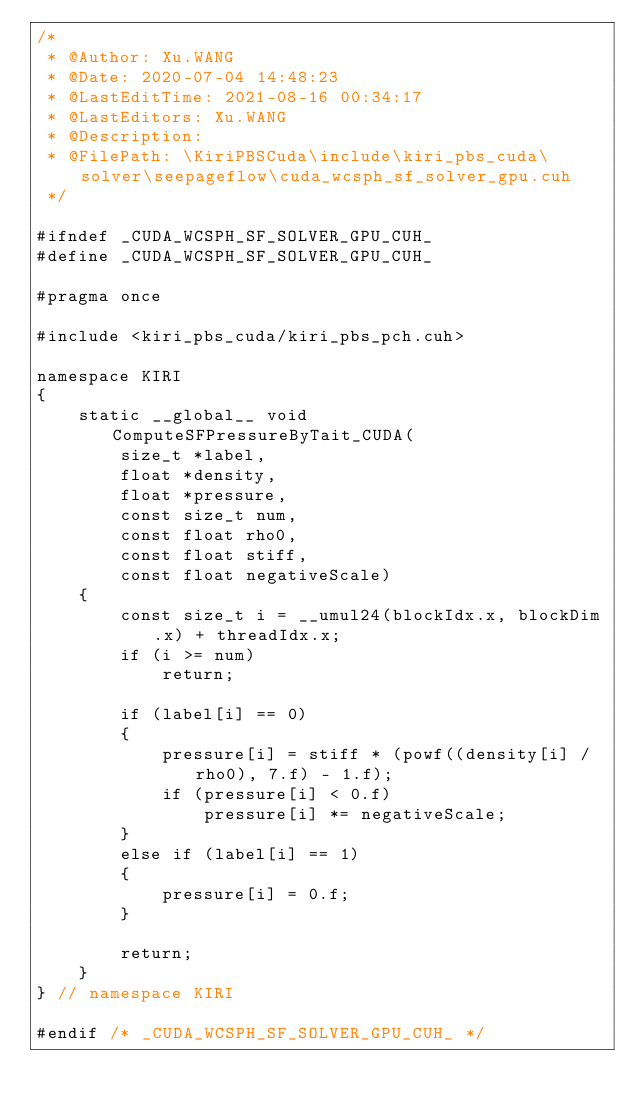<code> <loc_0><loc_0><loc_500><loc_500><_Cuda_>/*
 * @Author: Xu.WANG
 * @Date: 2020-07-04 14:48:23
 * @LastEditTime: 2021-08-16 00:34:17
 * @LastEditors: Xu.WANG
 * @Description: 
 * @FilePath: \KiriPBSCuda\include\kiri_pbs_cuda\solver\seepageflow\cuda_wcsph_sf_solver_gpu.cuh
 */

#ifndef _CUDA_WCSPH_SF_SOLVER_GPU_CUH_
#define _CUDA_WCSPH_SF_SOLVER_GPU_CUH_

#pragma once

#include <kiri_pbs_cuda/kiri_pbs_pch.cuh>

namespace KIRI
{
    static __global__ void ComputeSFPressureByTait_CUDA(
        size_t *label,
        float *density,
        float *pressure,
        const size_t num,
        const float rho0,
        const float stiff,
        const float negativeScale)
    {
        const size_t i = __umul24(blockIdx.x, blockDim.x) + threadIdx.x;
        if (i >= num)
            return;

        if (label[i] == 0)
        {
            pressure[i] = stiff * (powf((density[i] / rho0), 7.f) - 1.f);
            if (pressure[i] < 0.f)
                pressure[i] *= negativeScale;
        }
        else if (label[i] == 1)
        {
            pressure[i] = 0.f;
        }

        return;
    }
} // namespace KIRI

#endif /* _CUDA_WCSPH_SF_SOLVER_GPU_CUH_ */</code> 